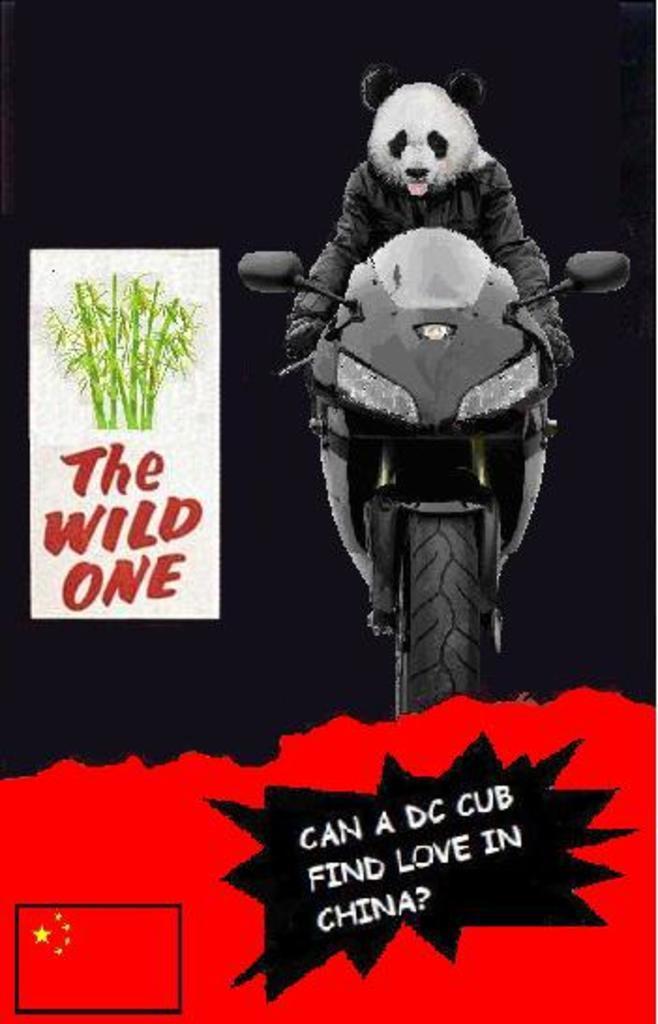Can you describe this image briefly? In this picture we can see a poster, in the poster we can find some text and a motorcycle. 